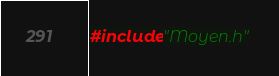<code> <loc_0><loc_0><loc_500><loc_500><_C++_>#include"Moyen.h"
</code> 